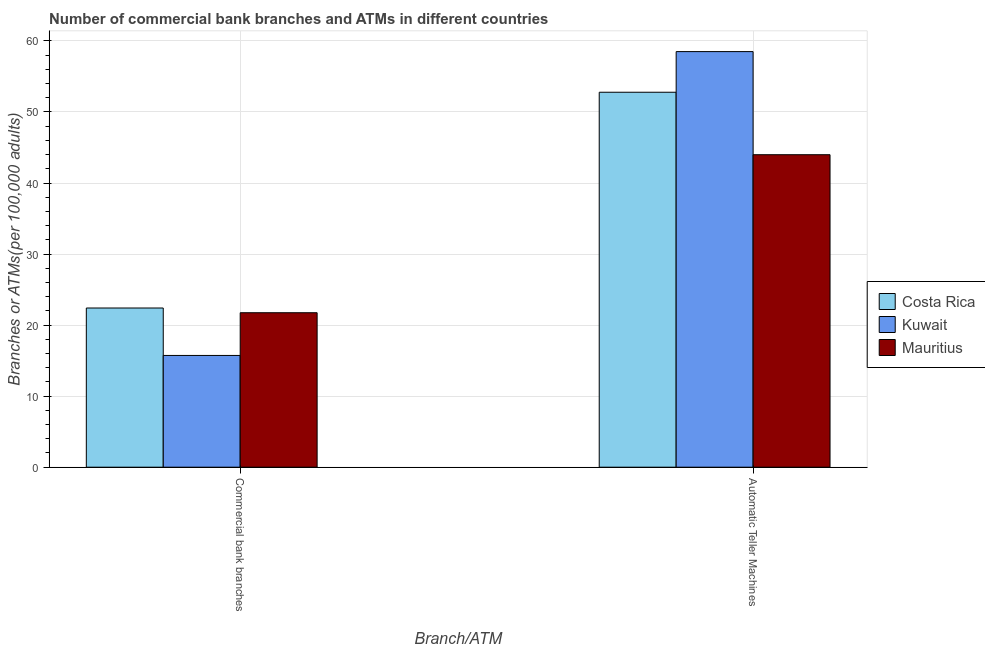How many groups of bars are there?
Your answer should be very brief. 2. Are the number of bars on each tick of the X-axis equal?
Your answer should be compact. Yes. What is the label of the 2nd group of bars from the left?
Your answer should be very brief. Automatic Teller Machines. What is the number of atms in Kuwait?
Provide a succinct answer. 58.5. Across all countries, what is the maximum number of atms?
Offer a very short reply. 58.5. Across all countries, what is the minimum number of commercal bank branches?
Provide a succinct answer. 15.73. In which country was the number of commercal bank branches maximum?
Your response must be concise. Costa Rica. In which country was the number of atms minimum?
Your answer should be very brief. Mauritius. What is the total number of atms in the graph?
Offer a very short reply. 155.27. What is the difference between the number of atms in Costa Rica and that in Mauritius?
Give a very brief answer. 8.79. What is the difference between the number of atms in Kuwait and the number of commercal bank branches in Mauritius?
Your answer should be compact. 36.76. What is the average number of atms per country?
Ensure brevity in your answer.  51.76. What is the difference between the number of atms and number of commercal bank branches in Kuwait?
Make the answer very short. 42.77. What is the ratio of the number of commercal bank branches in Costa Rica to that in Kuwait?
Ensure brevity in your answer.  1.42. Is the number of atms in Mauritius less than that in Costa Rica?
Keep it short and to the point. Yes. In how many countries, is the number of atms greater than the average number of atms taken over all countries?
Ensure brevity in your answer.  2. What does the 2nd bar from the left in Automatic Teller Machines represents?
Your answer should be compact. Kuwait. What does the 2nd bar from the right in Commercial bank branches represents?
Your answer should be very brief. Kuwait. Are all the bars in the graph horizontal?
Keep it short and to the point. No. How many countries are there in the graph?
Your answer should be very brief. 3. Are the values on the major ticks of Y-axis written in scientific E-notation?
Keep it short and to the point. No. How many legend labels are there?
Ensure brevity in your answer.  3. What is the title of the graph?
Make the answer very short. Number of commercial bank branches and ATMs in different countries. What is the label or title of the X-axis?
Your answer should be very brief. Branch/ATM. What is the label or title of the Y-axis?
Your response must be concise. Branches or ATMs(per 100,0 adults). What is the Branches or ATMs(per 100,000 adults) in Costa Rica in Commercial bank branches?
Provide a succinct answer. 22.41. What is the Branches or ATMs(per 100,000 adults) of Kuwait in Commercial bank branches?
Your response must be concise. 15.73. What is the Branches or ATMs(per 100,000 adults) of Mauritius in Commercial bank branches?
Your answer should be compact. 21.74. What is the Branches or ATMs(per 100,000 adults) in Costa Rica in Automatic Teller Machines?
Offer a very short reply. 52.78. What is the Branches or ATMs(per 100,000 adults) of Kuwait in Automatic Teller Machines?
Offer a very short reply. 58.5. What is the Branches or ATMs(per 100,000 adults) in Mauritius in Automatic Teller Machines?
Your answer should be very brief. 43.99. Across all Branch/ATM, what is the maximum Branches or ATMs(per 100,000 adults) in Costa Rica?
Keep it short and to the point. 52.78. Across all Branch/ATM, what is the maximum Branches or ATMs(per 100,000 adults) of Kuwait?
Provide a succinct answer. 58.5. Across all Branch/ATM, what is the maximum Branches or ATMs(per 100,000 adults) of Mauritius?
Offer a terse response. 43.99. Across all Branch/ATM, what is the minimum Branches or ATMs(per 100,000 adults) in Costa Rica?
Your answer should be very brief. 22.41. Across all Branch/ATM, what is the minimum Branches or ATMs(per 100,000 adults) of Kuwait?
Give a very brief answer. 15.73. Across all Branch/ATM, what is the minimum Branches or ATMs(per 100,000 adults) of Mauritius?
Ensure brevity in your answer.  21.74. What is the total Branches or ATMs(per 100,000 adults) in Costa Rica in the graph?
Offer a very short reply. 75.19. What is the total Branches or ATMs(per 100,000 adults) in Kuwait in the graph?
Ensure brevity in your answer.  74.23. What is the total Branches or ATMs(per 100,000 adults) in Mauritius in the graph?
Keep it short and to the point. 65.73. What is the difference between the Branches or ATMs(per 100,000 adults) in Costa Rica in Commercial bank branches and that in Automatic Teller Machines?
Offer a terse response. -30.37. What is the difference between the Branches or ATMs(per 100,000 adults) in Kuwait in Commercial bank branches and that in Automatic Teller Machines?
Your response must be concise. -42.77. What is the difference between the Branches or ATMs(per 100,000 adults) in Mauritius in Commercial bank branches and that in Automatic Teller Machines?
Give a very brief answer. -22.24. What is the difference between the Branches or ATMs(per 100,000 adults) of Costa Rica in Commercial bank branches and the Branches or ATMs(per 100,000 adults) of Kuwait in Automatic Teller Machines?
Ensure brevity in your answer.  -36.09. What is the difference between the Branches or ATMs(per 100,000 adults) of Costa Rica in Commercial bank branches and the Branches or ATMs(per 100,000 adults) of Mauritius in Automatic Teller Machines?
Your answer should be compact. -21.58. What is the difference between the Branches or ATMs(per 100,000 adults) of Kuwait in Commercial bank branches and the Branches or ATMs(per 100,000 adults) of Mauritius in Automatic Teller Machines?
Your answer should be very brief. -28.26. What is the average Branches or ATMs(per 100,000 adults) of Costa Rica per Branch/ATM?
Offer a terse response. 37.59. What is the average Branches or ATMs(per 100,000 adults) in Kuwait per Branch/ATM?
Offer a very short reply. 37.12. What is the average Branches or ATMs(per 100,000 adults) of Mauritius per Branch/ATM?
Your response must be concise. 32.87. What is the difference between the Branches or ATMs(per 100,000 adults) in Costa Rica and Branches or ATMs(per 100,000 adults) in Kuwait in Commercial bank branches?
Offer a terse response. 6.68. What is the difference between the Branches or ATMs(per 100,000 adults) of Costa Rica and Branches or ATMs(per 100,000 adults) of Mauritius in Commercial bank branches?
Your answer should be compact. 0.66. What is the difference between the Branches or ATMs(per 100,000 adults) of Kuwait and Branches or ATMs(per 100,000 adults) of Mauritius in Commercial bank branches?
Give a very brief answer. -6.01. What is the difference between the Branches or ATMs(per 100,000 adults) in Costa Rica and Branches or ATMs(per 100,000 adults) in Kuwait in Automatic Teller Machines?
Your answer should be very brief. -5.72. What is the difference between the Branches or ATMs(per 100,000 adults) in Costa Rica and Branches or ATMs(per 100,000 adults) in Mauritius in Automatic Teller Machines?
Your response must be concise. 8.79. What is the difference between the Branches or ATMs(per 100,000 adults) in Kuwait and Branches or ATMs(per 100,000 adults) in Mauritius in Automatic Teller Machines?
Offer a terse response. 14.51. What is the ratio of the Branches or ATMs(per 100,000 adults) in Costa Rica in Commercial bank branches to that in Automatic Teller Machines?
Your answer should be compact. 0.42. What is the ratio of the Branches or ATMs(per 100,000 adults) in Kuwait in Commercial bank branches to that in Automatic Teller Machines?
Keep it short and to the point. 0.27. What is the ratio of the Branches or ATMs(per 100,000 adults) in Mauritius in Commercial bank branches to that in Automatic Teller Machines?
Provide a short and direct response. 0.49. What is the difference between the highest and the second highest Branches or ATMs(per 100,000 adults) of Costa Rica?
Make the answer very short. 30.37. What is the difference between the highest and the second highest Branches or ATMs(per 100,000 adults) of Kuwait?
Make the answer very short. 42.77. What is the difference between the highest and the second highest Branches or ATMs(per 100,000 adults) in Mauritius?
Provide a short and direct response. 22.24. What is the difference between the highest and the lowest Branches or ATMs(per 100,000 adults) of Costa Rica?
Your answer should be compact. 30.37. What is the difference between the highest and the lowest Branches or ATMs(per 100,000 adults) in Kuwait?
Provide a succinct answer. 42.77. What is the difference between the highest and the lowest Branches or ATMs(per 100,000 adults) of Mauritius?
Your response must be concise. 22.24. 